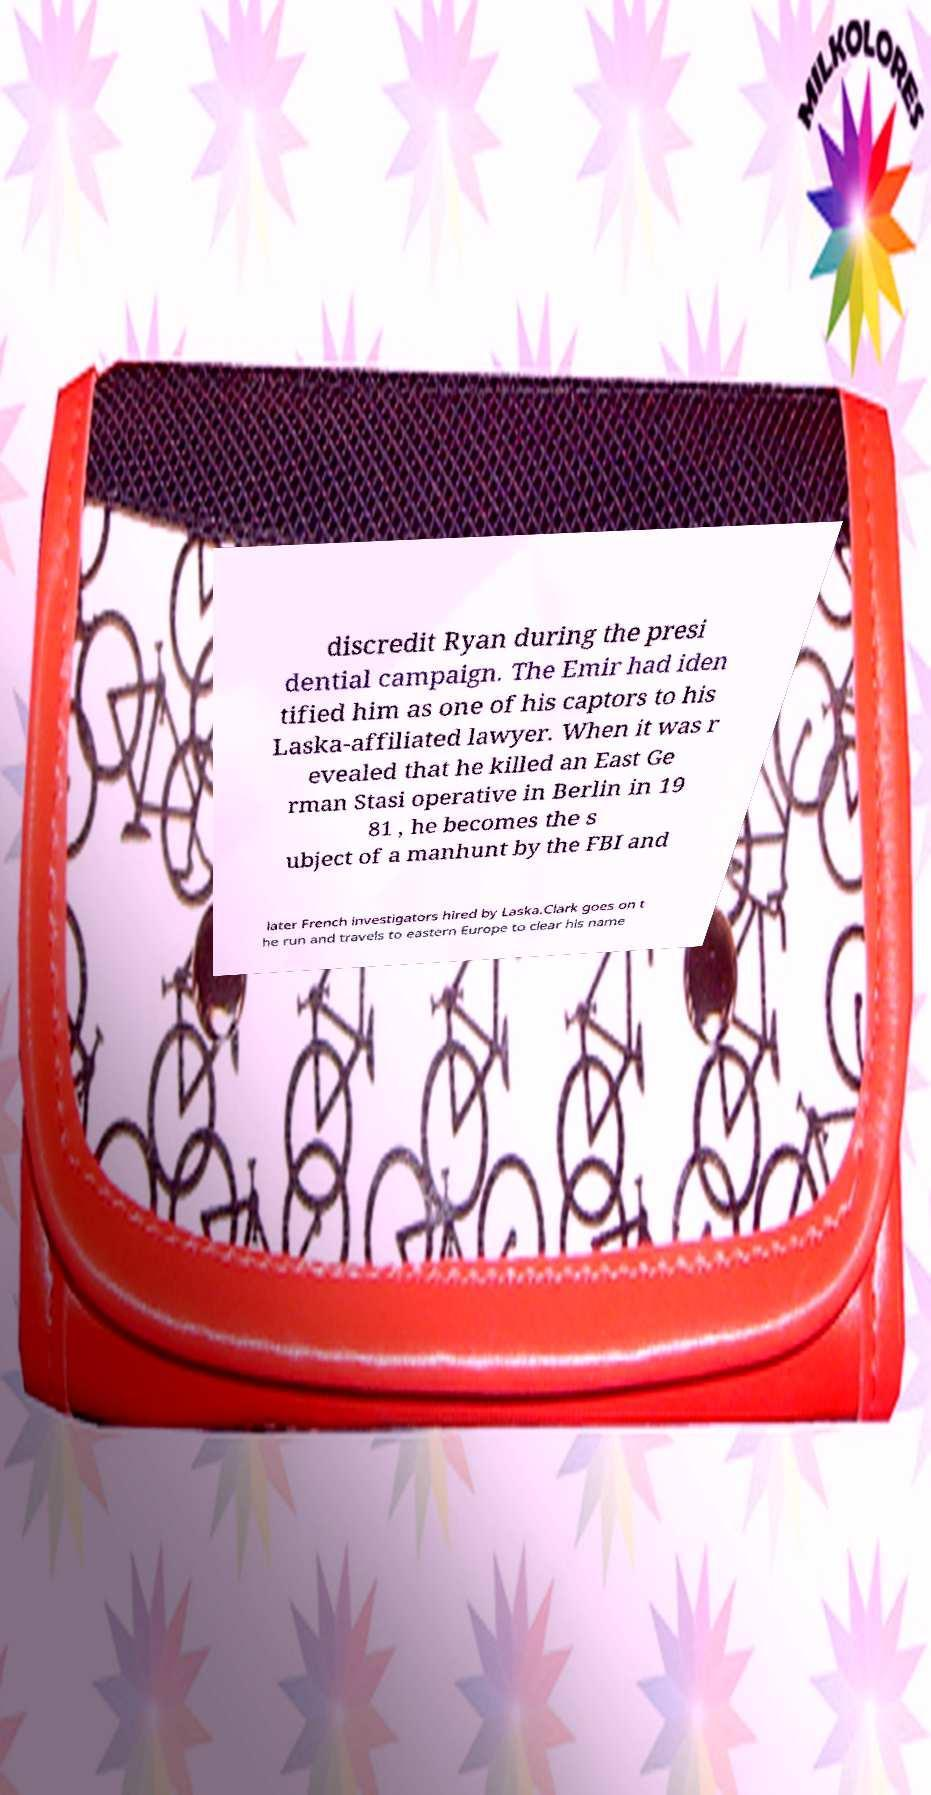Could you assist in decoding the text presented in this image and type it out clearly? discredit Ryan during the presi dential campaign. The Emir had iden tified him as one of his captors to his Laska-affiliated lawyer. When it was r evealed that he killed an East Ge rman Stasi operative in Berlin in 19 81 , he becomes the s ubject of a manhunt by the FBI and later French investigators hired by Laska.Clark goes on t he run and travels to eastern Europe to clear his name 